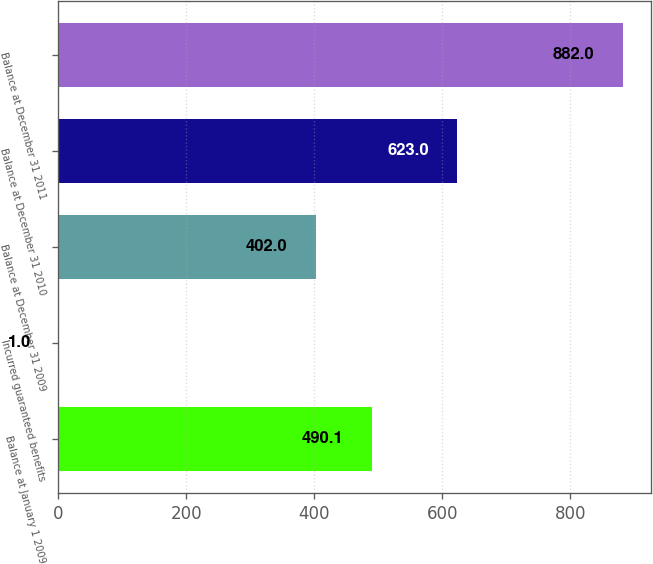Convert chart to OTSL. <chart><loc_0><loc_0><loc_500><loc_500><bar_chart><fcel>Balance at January 1 2009<fcel>Incurred guaranteed benefits<fcel>Balance at December 31 2009<fcel>Balance at December 31 2010<fcel>Balance at December 31 2011<nl><fcel>490.1<fcel>1<fcel>402<fcel>623<fcel>882<nl></chart> 